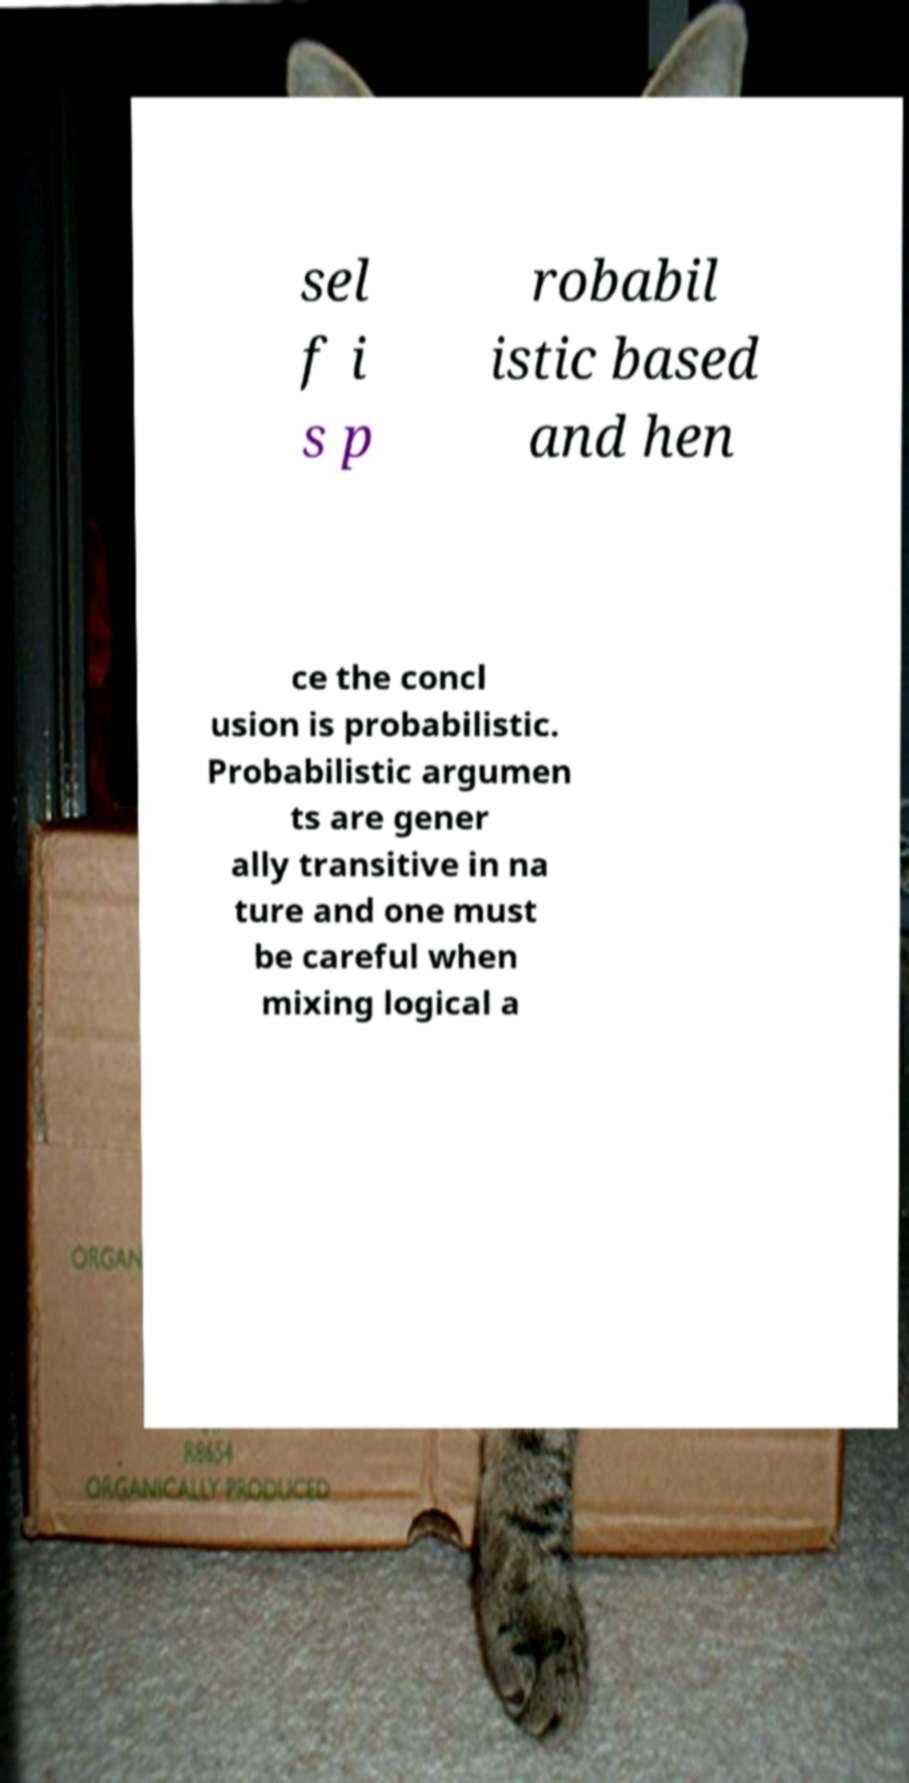Please read and relay the text visible in this image. What does it say? sel f i s p robabil istic based and hen ce the concl usion is probabilistic. Probabilistic argumen ts are gener ally transitive in na ture and one must be careful when mixing logical a 